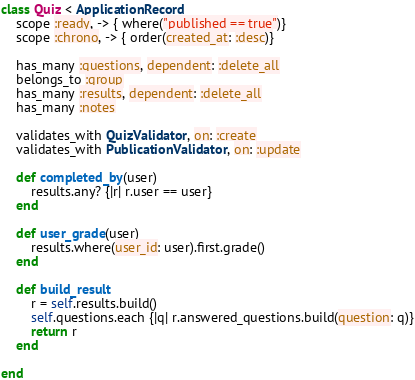<code> <loc_0><loc_0><loc_500><loc_500><_Ruby_>class Quiz < ApplicationRecord
    scope :ready, -> { where("published == true")}
    scope :chrono, -> { order(created_at: :desc)}

    has_many :questions, dependent: :delete_all
    belongs_to :group
    has_many :results, dependent: :delete_all
    has_many :notes
    
    validates_with QuizValidator, on: :create
    validates_with PublicationValidator, on: :update
    
    def completed_by(user)
        results.any? {|r| r.user == user}
    end

    def user_grade(user)
        results.where(user_id: user).first.grade()
    end

    def build_result
        r = self.results.build()
        self.questions.each {|q| r.answered_questions.build(question: q)}
        return r
    end

end
</code> 